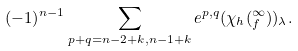<formula> <loc_0><loc_0><loc_500><loc_500>( - 1 ) ^ { n - 1 } \sum _ { p + q = n - 2 + k , n - 1 + k } e ^ { p , q } ( \chi _ { h } ( _ { f } ^ { \infty } ) ) _ { \lambda } .</formula> 